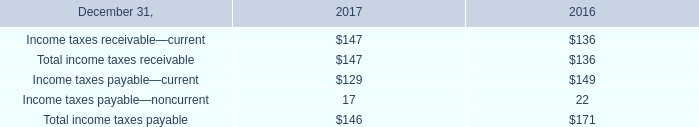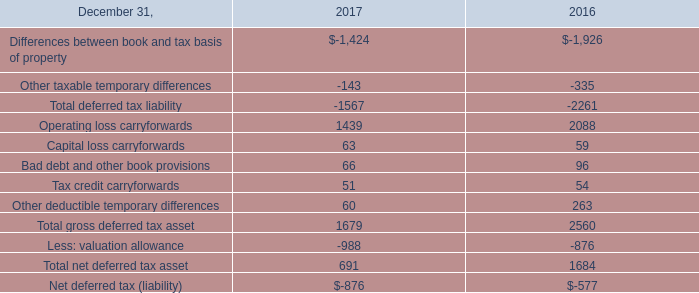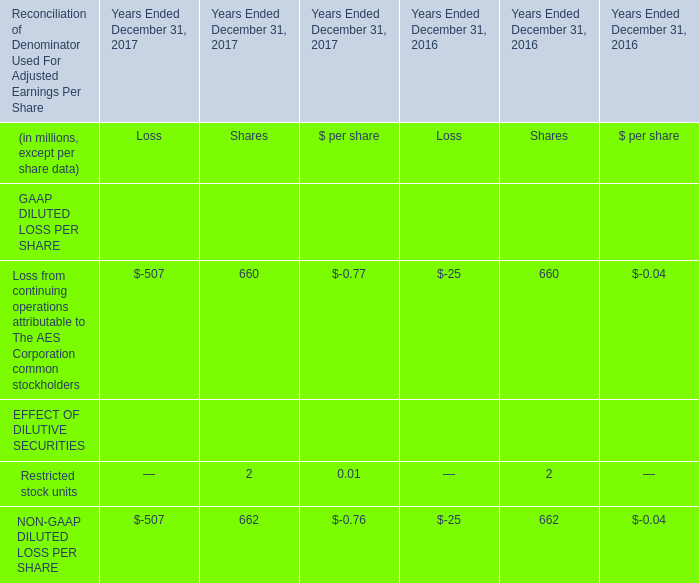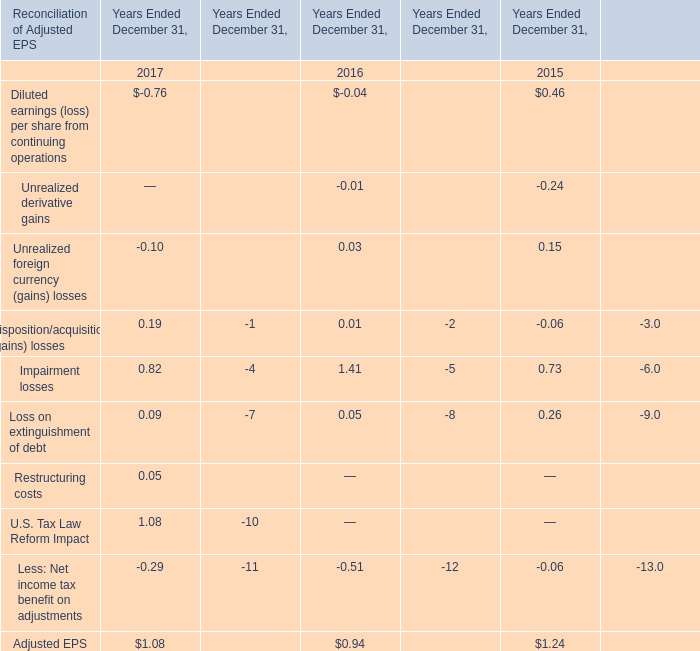Which year is Diluted earnings (loss) per share from continuing operations the least? 
Answer: -0.76. 